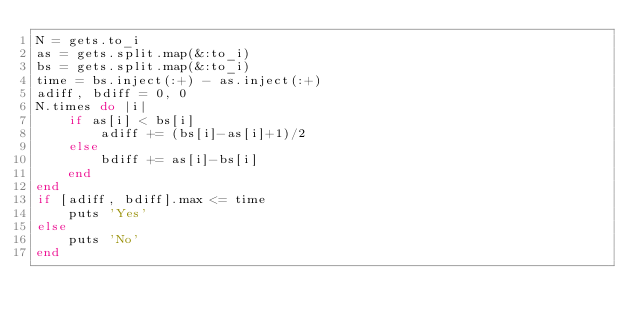Convert code to text. <code><loc_0><loc_0><loc_500><loc_500><_Ruby_>N = gets.to_i
as = gets.split.map(&:to_i)
bs = gets.split.map(&:to_i)
time = bs.inject(:+) - as.inject(:+)
adiff, bdiff = 0, 0
N.times do |i|
    if as[i] < bs[i]
        adiff += (bs[i]-as[i]+1)/2
    else
        bdiff += as[i]-bs[i]
    end
end
if [adiff, bdiff].max <= time
    puts 'Yes'
else
    puts 'No'
end</code> 